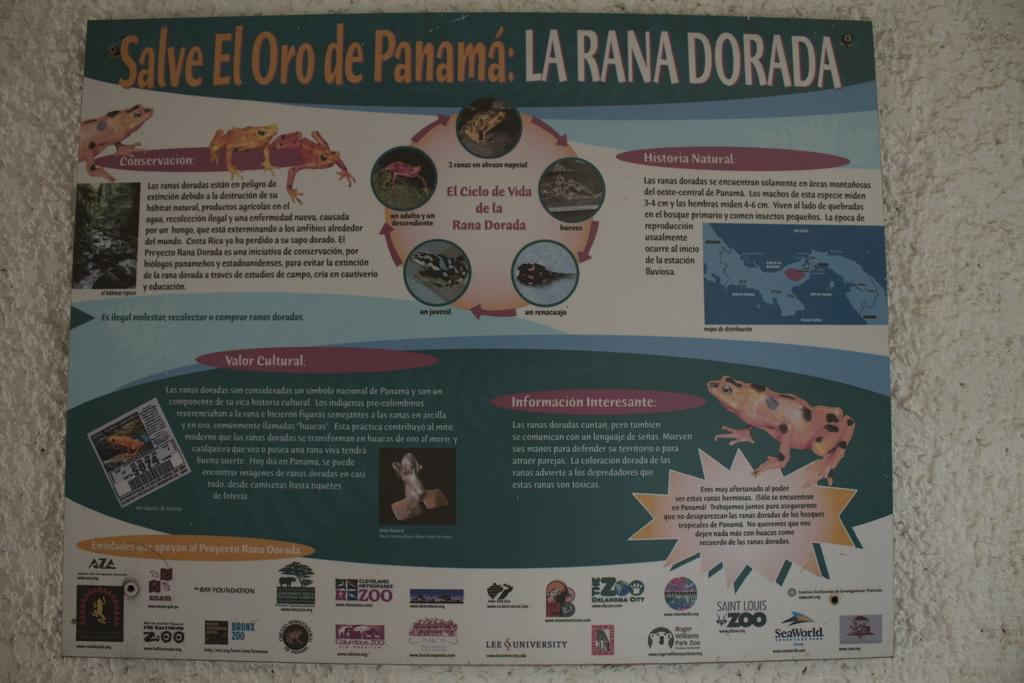<image>
Offer a succinct explanation of the picture presented. A brochure for La Rana Dorada featuring various toads and frogs. 